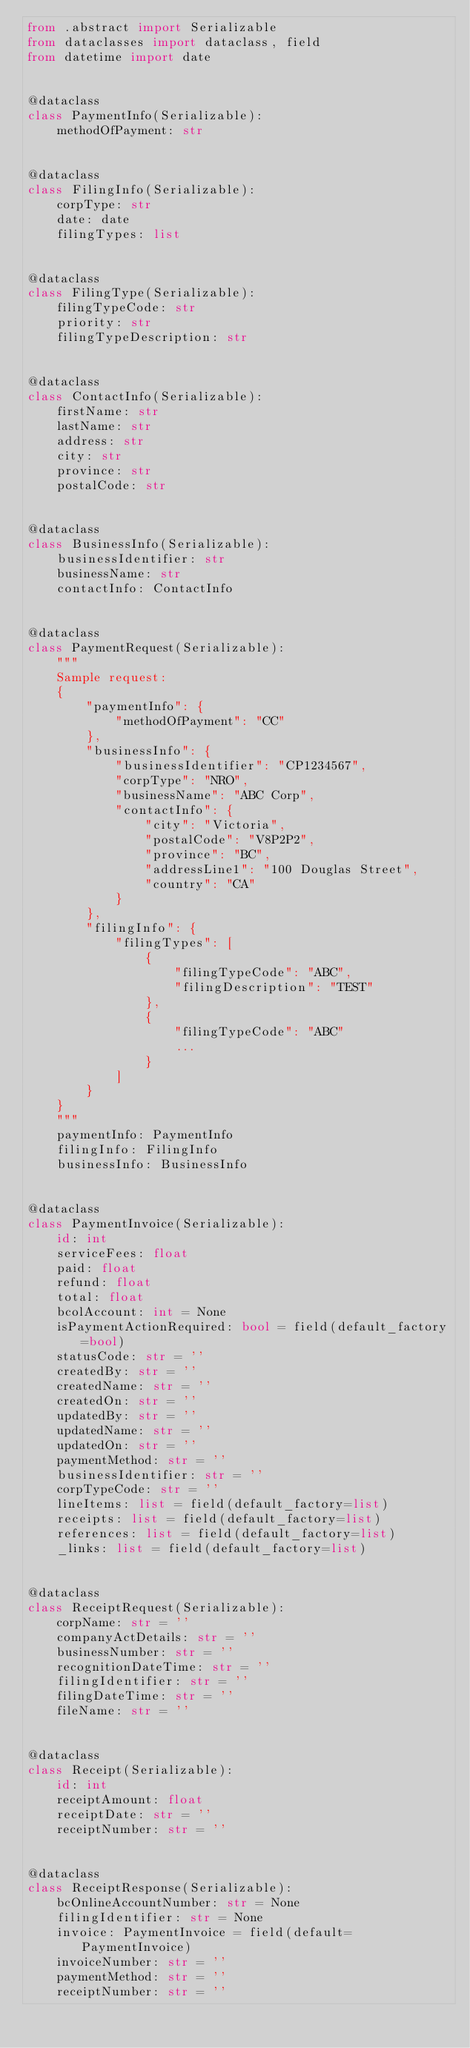<code> <loc_0><loc_0><loc_500><loc_500><_Python_>from .abstract import Serializable
from dataclasses import dataclass, field
from datetime import date


@dataclass
class PaymentInfo(Serializable):
    methodOfPayment: str


@dataclass
class FilingInfo(Serializable):
    corpType: str
    date: date
    filingTypes: list


@dataclass
class FilingType(Serializable):
    filingTypeCode: str
    priority: str
    filingTypeDescription: str


@dataclass
class ContactInfo(Serializable):
    firstName: str
    lastName: str
    address: str
    city: str
    province: str
    postalCode: str


@dataclass
class BusinessInfo(Serializable):
    businessIdentifier: str
    businessName: str
    contactInfo: ContactInfo


@dataclass
class PaymentRequest(Serializable):
    """
    Sample request:
    {
        "paymentInfo": {
            "methodOfPayment": "CC"
        },
        "businessInfo": {
            "businessIdentifier": "CP1234567",
            "corpType": "NRO",
            "businessName": "ABC Corp",
            "contactInfo": {
                "city": "Victoria",
                "postalCode": "V8P2P2",
                "province": "BC",
                "addressLine1": "100 Douglas Street",
                "country": "CA"
            }
        },
        "filingInfo": {
            "filingTypes": [
                {
                    "filingTypeCode": "ABC",
                    "filingDescription": "TEST"
                },
                {
                    "filingTypeCode": "ABC"
                    ...
                }
            ]
        }
    }
    """
    paymentInfo: PaymentInfo
    filingInfo: FilingInfo
    businessInfo: BusinessInfo


@dataclass
class PaymentInvoice(Serializable):
    id: int
    serviceFees: float
    paid: float
    refund: float
    total: float
    bcolAccount: int = None
    isPaymentActionRequired: bool = field(default_factory=bool)
    statusCode: str = ''
    createdBy: str = ''
    createdName: str = ''
    createdOn: str = ''
    updatedBy: str = ''
    updatedName: str = ''
    updatedOn: str = ''
    paymentMethod: str = ''
    businessIdentifier: str = ''
    corpTypeCode: str = ''
    lineItems: list = field(default_factory=list)
    receipts: list = field(default_factory=list)
    references: list = field(default_factory=list)
    _links: list = field(default_factory=list)


@dataclass
class ReceiptRequest(Serializable):
    corpName: str = ''
    companyActDetails: str = ''
    businessNumber: str = ''
    recognitionDateTime: str = ''
    filingIdentifier: str = ''
    filingDateTime: str = ''
    fileName: str = ''


@dataclass
class Receipt(Serializable):
    id: int
    receiptAmount: float
    receiptDate: str = ''
    receiptNumber: str = ''


@dataclass
class ReceiptResponse(Serializable):
    bcOnlineAccountNumber: str = None
    filingIdentifier: str = None
    invoice: PaymentInvoice = field(default=PaymentInvoice)
    invoiceNumber: str = ''
    paymentMethod: str = ''
    receiptNumber: str = ''
</code> 